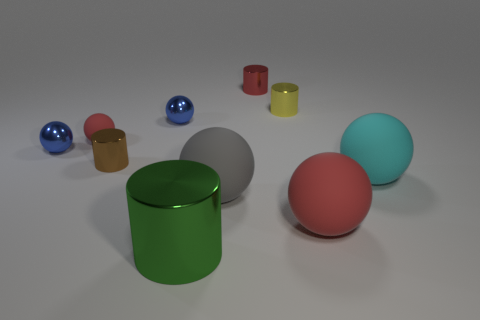What material is the big ball that is the same color as the small rubber object?
Offer a very short reply. Rubber. Do the big rubber thing in front of the gray rubber sphere and the tiny matte object have the same color?
Your response must be concise. Yes. There is a small matte sphere; is its color the same as the ball that is in front of the gray rubber ball?
Your answer should be very brief. Yes. There is a red rubber thing that is on the right side of the big green metal cylinder; is its shape the same as the red rubber object that is left of the green object?
Provide a short and direct response. Yes. What number of objects are tiny balls or large gray metal objects?
Keep it short and to the point. 3. What size is the gray object that is the same shape as the cyan matte thing?
Your answer should be very brief. Large. Is the number of tiny yellow metallic things in front of the tiny rubber sphere greater than the number of large gray balls?
Give a very brief answer. No. Is the large gray object made of the same material as the large red sphere?
Keep it short and to the point. Yes. How many things are either rubber things that are on the right side of the large green cylinder or yellow metal things that are behind the tiny brown shiny cylinder?
Provide a succinct answer. 4. There is a big metallic object that is the same shape as the small red shiny thing; what color is it?
Your answer should be compact. Green. 